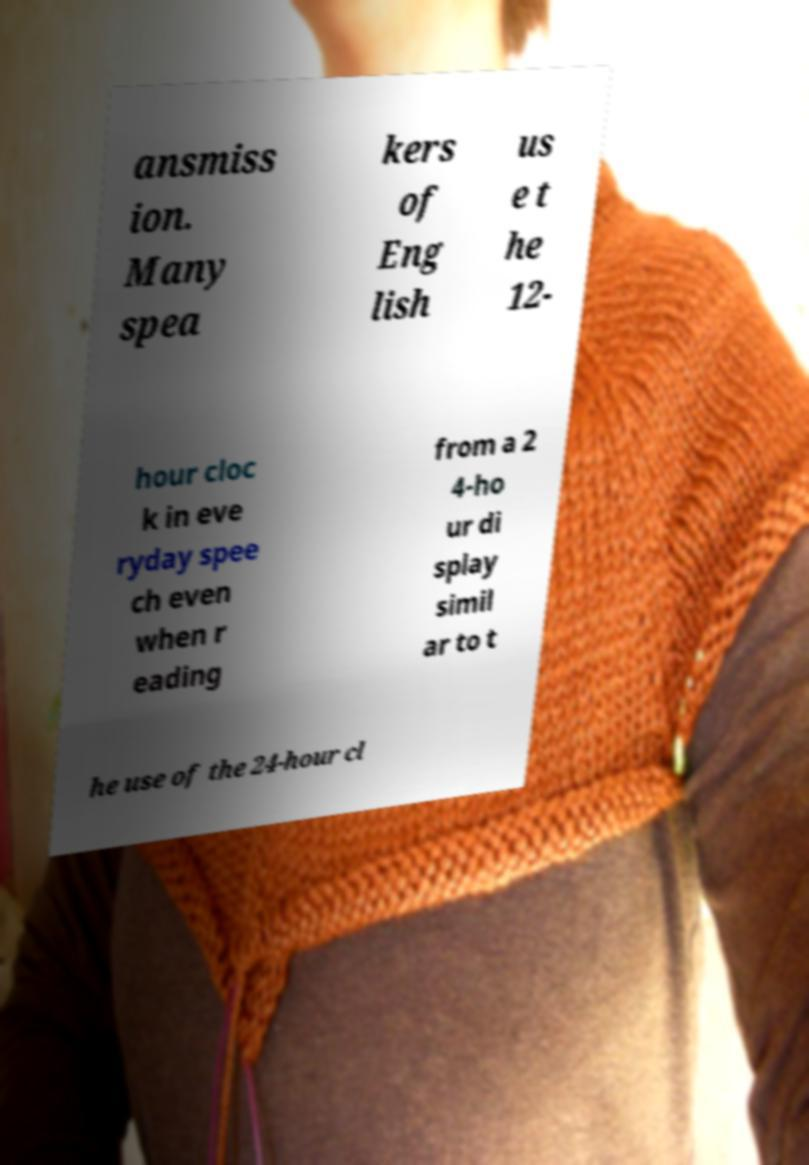Could you assist in decoding the text presented in this image and type it out clearly? ansmiss ion. Many spea kers of Eng lish us e t he 12- hour cloc k in eve ryday spee ch even when r eading from a 2 4-ho ur di splay simil ar to t he use of the 24-hour cl 